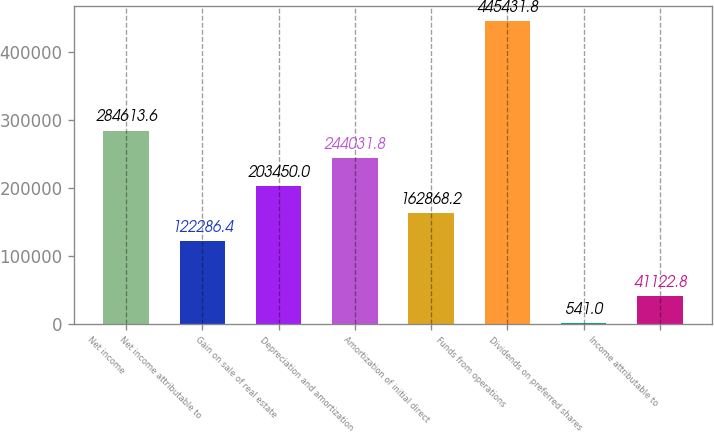Convert chart. <chart><loc_0><loc_0><loc_500><loc_500><bar_chart><fcel>Net income<fcel>Net income attributable to<fcel>Gain on sale of real estate<fcel>Depreciation and amortization<fcel>Amortization of initial direct<fcel>Funds from operations<fcel>Dividends on preferred shares<fcel>Income attributable to<nl><fcel>284614<fcel>122286<fcel>203450<fcel>244032<fcel>162868<fcel>445432<fcel>541<fcel>41122.8<nl></chart> 